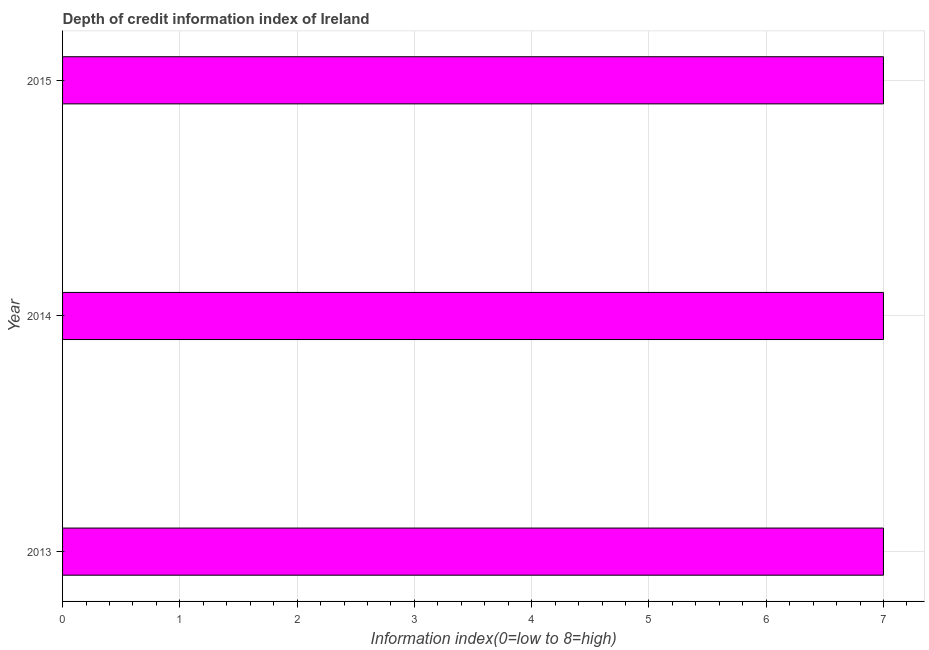Does the graph contain any zero values?
Offer a very short reply. No. What is the title of the graph?
Offer a terse response. Depth of credit information index of Ireland. What is the label or title of the X-axis?
Offer a terse response. Information index(0=low to 8=high). What is the sum of the depth of credit information index?
Provide a succinct answer. 21. What is the median depth of credit information index?
Provide a succinct answer. 7. Do a majority of the years between 2014 and 2013 (inclusive) have depth of credit information index greater than 6 ?
Keep it short and to the point. No. What is the ratio of the depth of credit information index in 2014 to that in 2015?
Your answer should be compact. 1. Is the difference between the depth of credit information index in 2013 and 2014 greater than the difference between any two years?
Ensure brevity in your answer.  Yes. How many years are there in the graph?
Your answer should be very brief. 3. Are the values on the major ticks of X-axis written in scientific E-notation?
Ensure brevity in your answer.  No. What is the Information index(0=low to 8=high) of 2014?
Keep it short and to the point. 7. What is the Information index(0=low to 8=high) in 2015?
Your answer should be compact. 7. What is the difference between the Information index(0=low to 8=high) in 2013 and 2014?
Offer a very short reply. 0. What is the difference between the Information index(0=low to 8=high) in 2013 and 2015?
Provide a short and direct response. 0. 